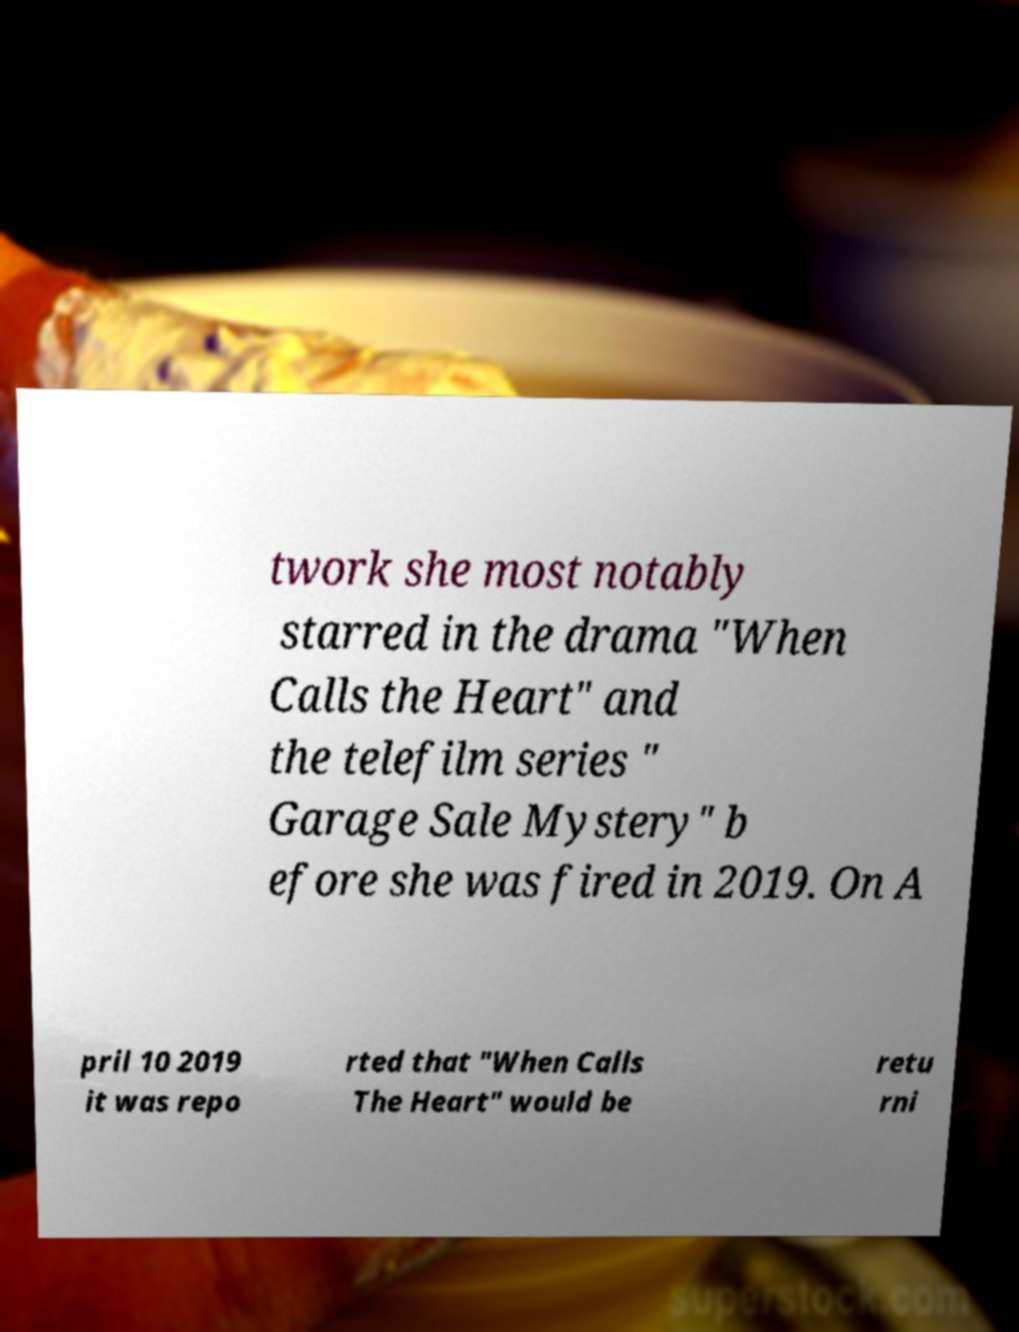Can you accurately transcribe the text from the provided image for me? twork she most notably starred in the drama "When Calls the Heart" and the telefilm series " Garage Sale Mystery" b efore she was fired in 2019. On A pril 10 2019 it was repo rted that "When Calls The Heart" would be retu rni 